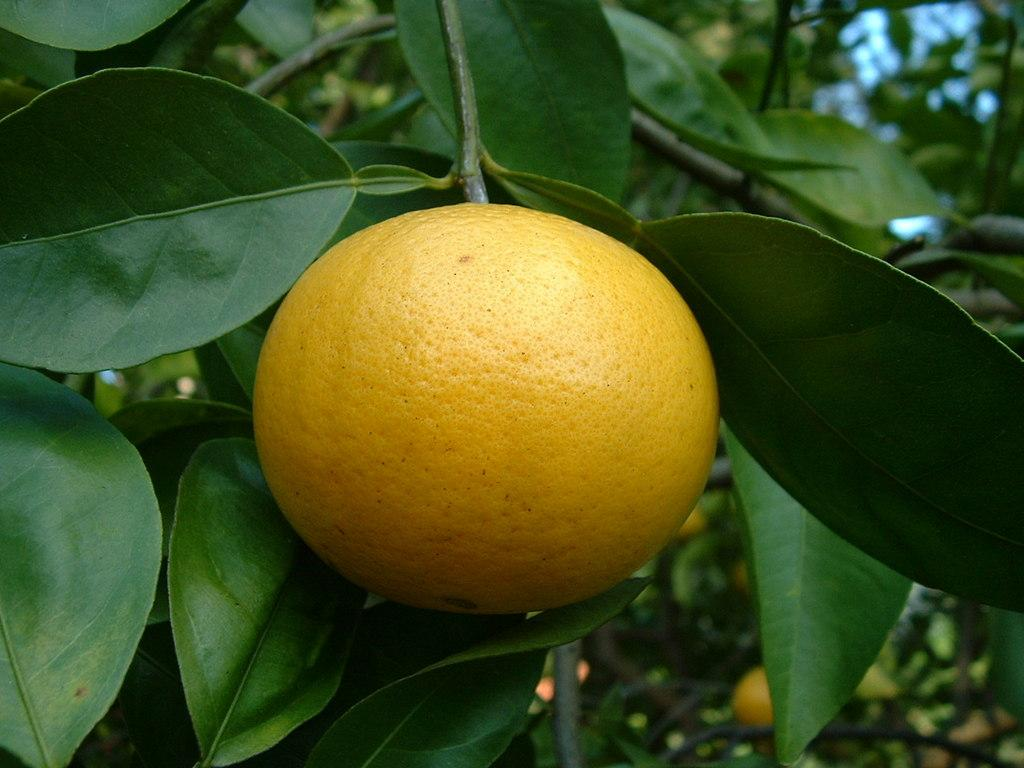What type of fruit can be seen on the trees in the image? There are oranges on trees in the image. How many oranges can be seen on each tree? The number of oranges on each tree cannot be determined from the image alone. What is the color of the oranges on the trees? The oranges on the trees appear to be orange in color. What type of band is performing in the image? There is no band present in the image; it only features oranges on trees. 